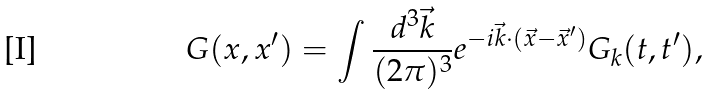<formula> <loc_0><loc_0><loc_500><loc_500>G ( x , x ^ { \prime } ) = \int \frac { d ^ { 3 } \vec { k } } { ( 2 \pi ) ^ { 3 } } e ^ { - i \vec { k } \cdot ( \vec { x } - \vec { x } ^ { \prime } ) } G _ { k } ( t , t ^ { \prime } ) ,</formula> 